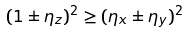Convert formula to latex. <formula><loc_0><loc_0><loc_500><loc_500>( 1 \pm \eta _ { z } ) ^ { 2 } \geq ( \eta _ { x } \pm \eta _ { y } ) ^ { 2 }</formula> 